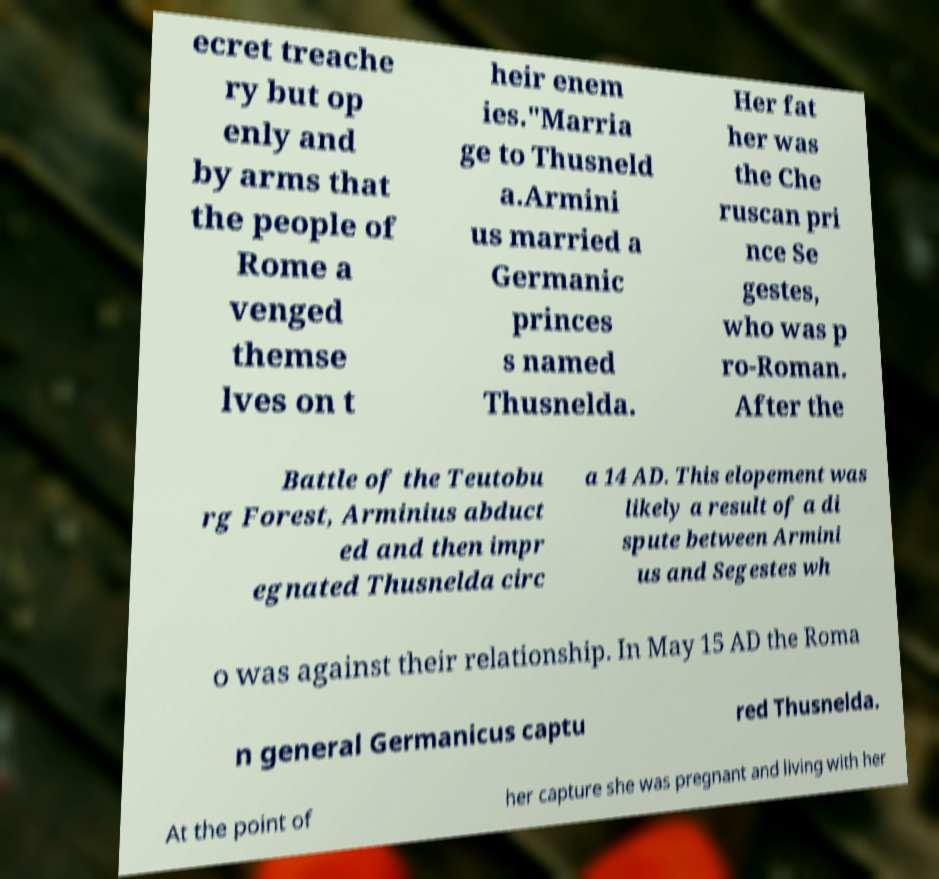I need the written content from this picture converted into text. Can you do that? ecret treache ry but op enly and by arms that the people of Rome a venged themse lves on t heir enem ies."Marria ge to Thusneld a.Armini us married a Germanic princes s named Thusnelda. Her fat her was the Che ruscan pri nce Se gestes, who was p ro-Roman. After the Battle of the Teutobu rg Forest, Arminius abduct ed and then impr egnated Thusnelda circ a 14 AD. This elopement was likely a result of a di spute between Armini us and Segestes wh o was against their relationship. In May 15 AD the Roma n general Germanicus captu red Thusnelda. At the point of her capture she was pregnant and living with her 